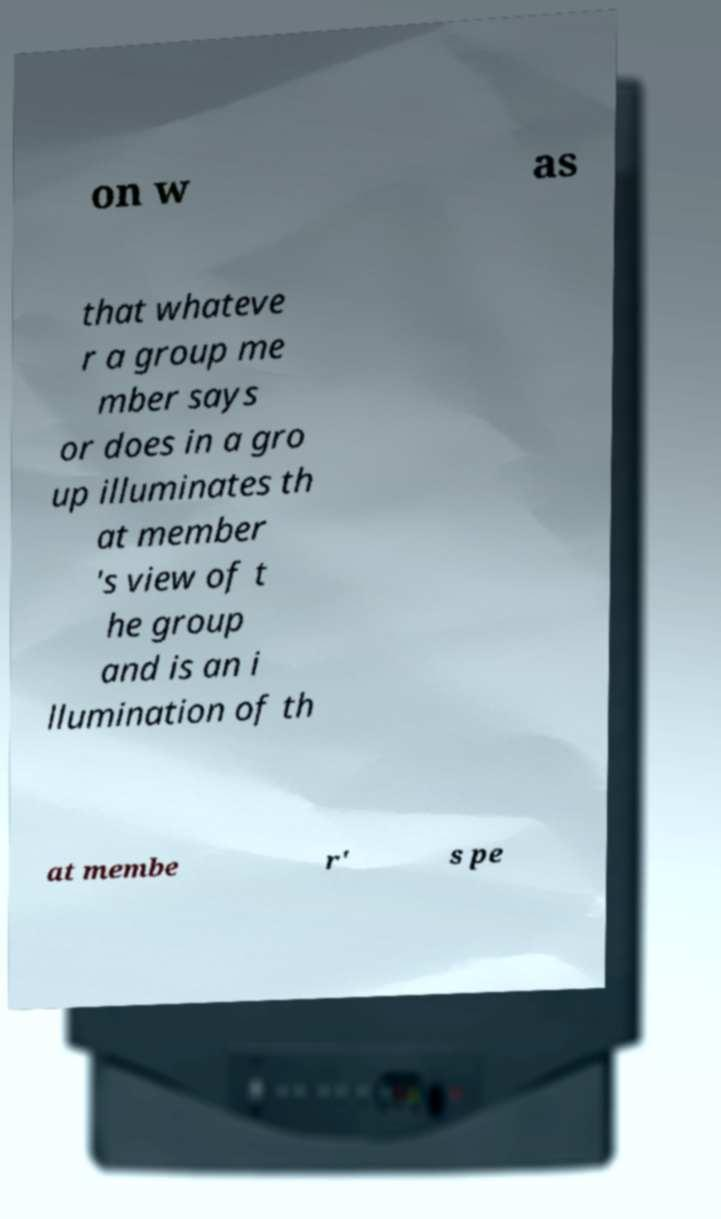What messages or text are displayed in this image? I need them in a readable, typed format. on w as that whateve r a group me mber says or does in a gro up illuminates th at member 's view of t he group and is an i llumination of th at membe r' s pe 